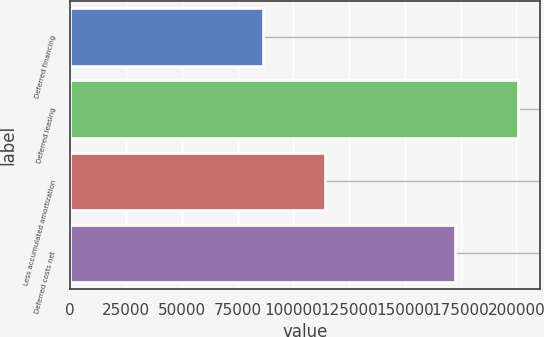Convert chart. <chart><loc_0><loc_0><loc_500><loc_500><bar_chart><fcel>Deferred financing<fcel>Deferred leasing<fcel>Less accumulated amortization<fcel>Deferred costs net<nl><fcel>86256<fcel>200633<fcel>114372<fcel>172517<nl></chart> 